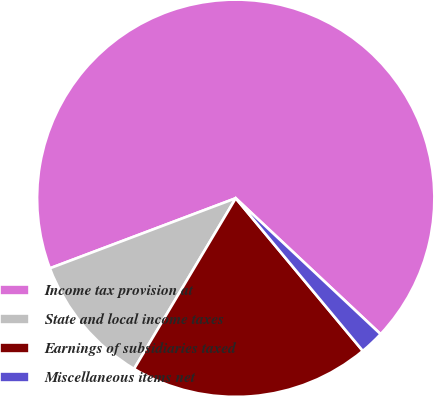<chart> <loc_0><loc_0><loc_500><loc_500><pie_chart><fcel>Income tax provision at<fcel>State and local income taxes<fcel>Earnings of subsidiaries taxed<fcel>Miscellaneous items net<nl><fcel>67.73%<fcel>10.71%<fcel>19.6%<fcel>1.96%<nl></chart> 